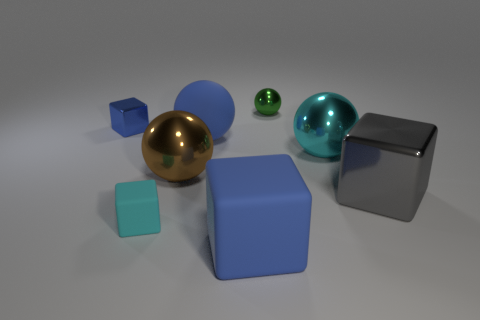Subtract 1 cubes. How many cubes are left? 3 Add 2 cyan cubes. How many objects exist? 10 Subtract all matte cylinders. Subtract all blue balls. How many objects are left? 7 Add 5 small balls. How many small balls are left? 6 Add 3 big cyan spheres. How many big cyan spheres exist? 4 Subtract 0 gray cylinders. How many objects are left? 8 